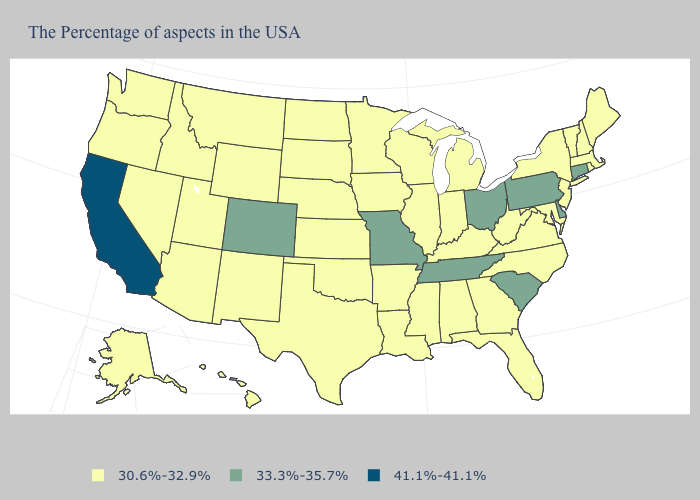What is the lowest value in the USA?
Write a very short answer. 30.6%-32.9%. What is the value of Iowa?
Keep it brief. 30.6%-32.9%. What is the value of Indiana?
Answer briefly. 30.6%-32.9%. Does the map have missing data?
Be succinct. No. What is the value of New Hampshire?
Concise answer only. 30.6%-32.9%. What is the value of Indiana?
Keep it brief. 30.6%-32.9%. What is the highest value in states that border Wyoming?
Quick response, please. 33.3%-35.7%. What is the value of Louisiana?
Concise answer only. 30.6%-32.9%. What is the highest value in the USA?
Answer briefly. 41.1%-41.1%. Among the states that border Oregon , which have the lowest value?
Write a very short answer. Idaho, Nevada, Washington. Does Maine have the lowest value in the Northeast?
Keep it brief. Yes. Is the legend a continuous bar?
Keep it brief. No. Which states have the lowest value in the USA?
Quick response, please. Maine, Massachusetts, Rhode Island, New Hampshire, Vermont, New York, New Jersey, Maryland, Virginia, North Carolina, West Virginia, Florida, Georgia, Michigan, Kentucky, Indiana, Alabama, Wisconsin, Illinois, Mississippi, Louisiana, Arkansas, Minnesota, Iowa, Kansas, Nebraska, Oklahoma, Texas, South Dakota, North Dakota, Wyoming, New Mexico, Utah, Montana, Arizona, Idaho, Nevada, Washington, Oregon, Alaska, Hawaii. Does Nebraska have the same value as Mississippi?
Answer briefly. Yes. Among the states that border South Dakota , which have the highest value?
Concise answer only. Minnesota, Iowa, Nebraska, North Dakota, Wyoming, Montana. 